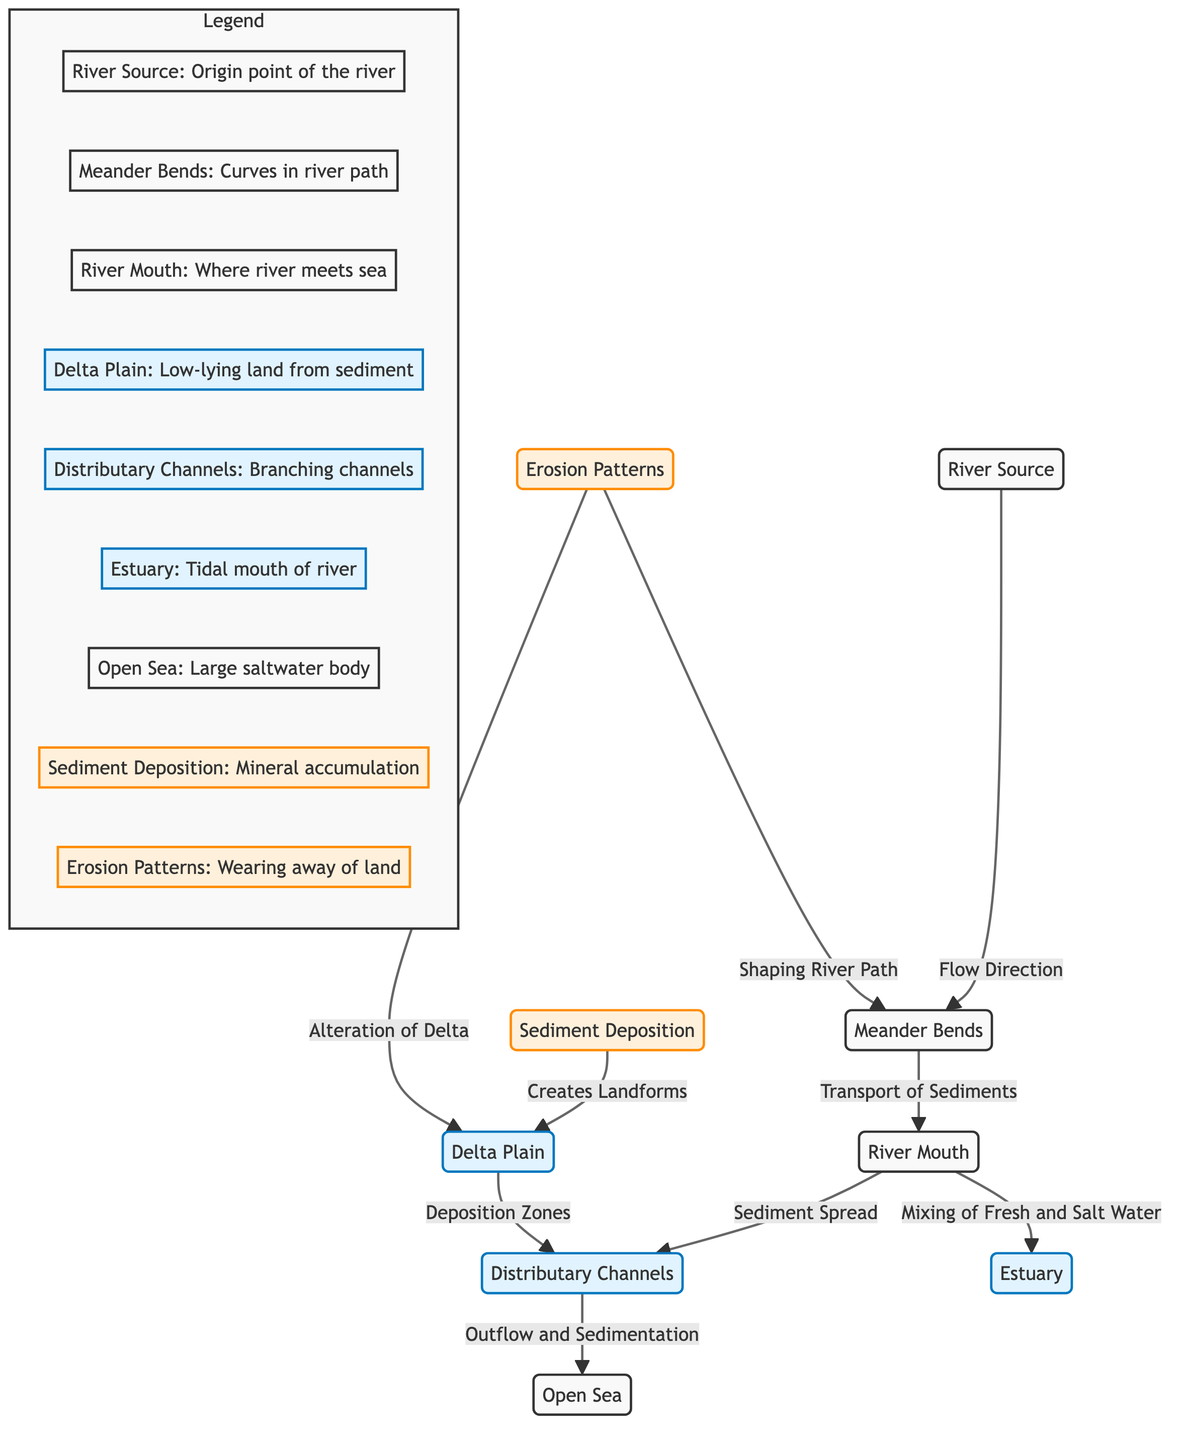What is the origin point of the river? The diagram identifies the origin point of the river as "River Source." This node is clearly labeled and directly indicates where the river begins its flow.
Answer: River Source How do sediments travel from the Meander Bends to the River Mouth? The diagram shows an arrow labeled "Transport of Sediments" connecting "Meander Bends" to "River Mouth." This indicates the direct relationship and process of sediment movement from the bends to the mouth of the river.
Answer: Transport of Sediments What two interactions occur at the River Mouth? Based on the diagram, two interactions at the River Mouth are "Sediment Spread" towards Distributary Channels and "Mixing of Fresh and Salt Water" towards the Estuary. Both are depicted as outgoing arrows from the River Mouth node.
Answer: Sediment Spread and Mixing of Fresh and Salt Water Which process creates landforms in the Delta Plain? The diagram identifies "Sediment Deposition" as creating landforms in the Delta Plain. The relationship is clearly indicated with an arrow pointing from Sediment Deposition to Delta Plain, denoting the outcome of deposition.
Answer: Sediment Deposition What effect do Erosion Patterns have on the Delta? The diagram indicates that Erosion Patterns lead to "Alteration of Delta," as shown by an arrow connecting Erosion Patterns to Delta Plain. This suggests that erosion changes the structure of the delta over time.
Answer: Alteration of Delta How many main sections are represented in the diagram? The diagram consists of five main sections: River Source, Meander Bends, River Mouth, Delta Plain, and Distributary Channels, plus Estuary and Open Sea. Each section is distinctly colored and labeled, allowing for easy counting.
Answer: Five What leads to the "Outflow and Sedimentation" in Distributary Channels? According to the diagram, "Outflow and Sedimentation" result from the Distributary Channels leading to the Open Sea. This is depicted with an arrow connecting these two processes, clearly showing the flow direction.
Answer: Distributary Channels What role does the Estuary play within this diagram? The diagram indicates that the Estuary serves as the "Tidal mouth of river," showing its function as a mixing zone between fresh and saltwater, illustrated by its connection to both the River Mouth and Open Sea.
Answer: Tidal mouth of river What processes are involved in shaping the river path? The diagram shows that "Erosion Patterns" are responsible for "Shaping River Path." This connection makes it clear that erosion processes play a vital role in altering the river's course over time.
Answer: Shaping River Path 